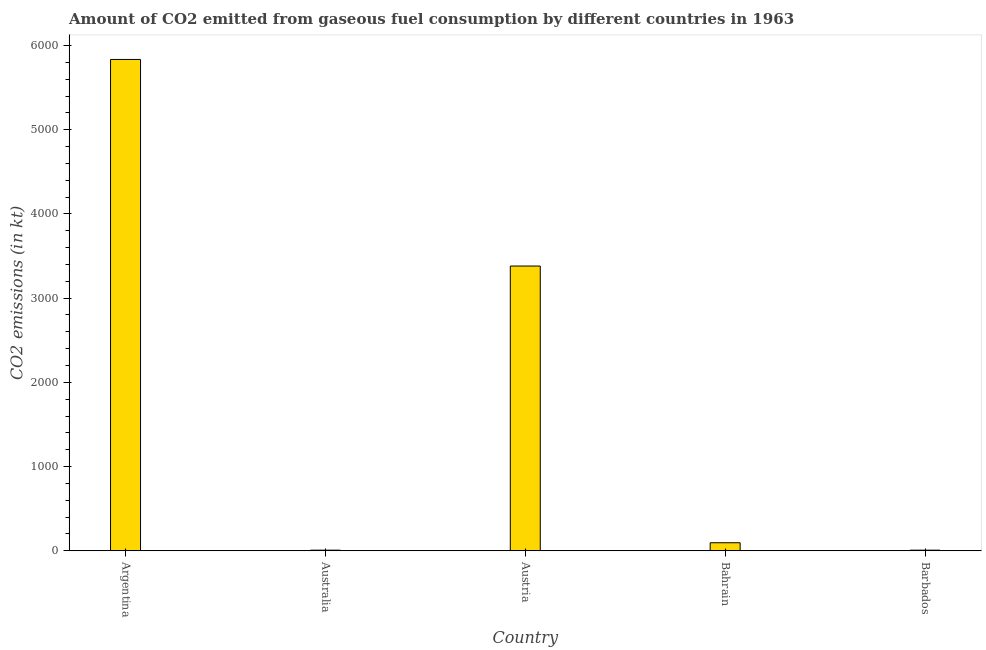Does the graph contain any zero values?
Provide a short and direct response. No. What is the title of the graph?
Ensure brevity in your answer.  Amount of CO2 emitted from gaseous fuel consumption by different countries in 1963. What is the label or title of the X-axis?
Ensure brevity in your answer.  Country. What is the label or title of the Y-axis?
Offer a very short reply. CO2 emissions (in kt). What is the co2 emissions from gaseous fuel consumption in Austria?
Offer a very short reply. 3380.97. Across all countries, what is the maximum co2 emissions from gaseous fuel consumption?
Your answer should be very brief. 5834.2. Across all countries, what is the minimum co2 emissions from gaseous fuel consumption?
Ensure brevity in your answer.  7.33. In which country was the co2 emissions from gaseous fuel consumption maximum?
Your answer should be very brief. Argentina. What is the sum of the co2 emissions from gaseous fuel consumption?
Your answer should be very brief. 9325.18. What is the difference between the co2 emissions from gaseous fuel consumption in Bahrain and Barbados?
Your response must be concise. 88.01. What is the average co2 emissions from gaseous fuel consumption per country?
Your answer should be very brief. 1865.04. What is the median co2 emissions from gaseous fuel consumption?
Provide a succinct answer. 95.34. What is the ratio of the co2 emissions from gaseous fuel consumption in Argentina to that in Bahrain?
Make the answer very short. 61.19. Is the difference between the co2 emissions from gaseous fuel consumption in Australia and Barbados greater than the difference between any two countries?
Provide a short and direct response. No. What is the difference between the highest and the second highest co2 emissions from gaseous fuel consumption?
Your response must be concise. 2453.22. What is the difference between the highest and the lowest co2 emissions from gaseous fuel consumption?
Offer a very short reply. 5826.86. In how many countries, is the co2 emissions from gaseous fuel consumption greater than the average co2 emissions from gaseous fuel consumption taken over all countries?
Your response must be concise. 2. How many bars are there?
Your response must be concise. 5. How many countries are there in the graph?
Offer a terse response. 5. Are the values on the major ticks of Y-axis written in scientific E-notation?
Your answer should be very brief. No. What is the CO2 emissions (in kt) of Argentina?
Your response must be concise. 5834.2. What is the CO2 emissions (in kt) in Australia?
Your answer should be very brief. 7.33. What is the CO2 emissions (in kt) of Austria?
Your answer should be compact. 3380.97. What is the CO2 emissions (in kt) in Bahrain?
Offer a very short reply. 95.34. What is the CO2 emissions (in kt) in Barbados?
Give a very brief answer. 7.33. What is the difference between the CO2 emissions (in kt) in Argentina and Australia?
Make the answer very short. 5826.86. What is the difference between the CO2 emissions (in kt) in Argentina and Austria?
Provide a short and direct response. 2453.22. What is the difference between the CO2 emissions (in kt) in Argentina and Bahrain?
Your response must be concise. 5738.85. What is the difference between the CO2 emissions (in kt) in Argentina and Barbados?
Your answer should be compact. 5826.86. What is the difference between the CO2 emissions (in kt) in Australia and Austria?
Offer a terse response. -3373.64. What is the difference between the CO2 emissions (in kt) in Australia and Bahrain?
Your answer should be compact. -88.01. What is the difference between the CO2 emissions (in kt) in Australia and Barbados?
Provide a succinct answer. 0. What is the difference between the CO2 emissions (in kt) in Austria and Bahrain?
Your response must be concise. 3285.63. What is the difference between the CO2 emissions (in kt) in Austria and Barbados?
Your answer should be compact. 3373.64. What is the difference between the CO2 emissions (in kt) in Bahrain and Barbados?
Give a very brief answer. 88.01. What is the ratio of the CO2 emissions (in kt) in Argentina to that in Australia?
Your answer should be very brief. 795.5. What is the ratio of the CO2 emissions (in kt) in Argentina to that in Austria?
Your answer should be very brief. 1.73. What is the ratio of the CO2 emissions (in kt) in Argentina to that in Bahrain?
Provide a succinct answer. 61.19. What is the ratio of the CO2 emissions (in kt) in Argentina to that in Barbados?
Give a very brief answer. 795.5. What is the ratio of the CO2 emissions (in kt) in Australia to that in Austria?
Your response must be concise. 0. What is the ratio of the CO2 emissions (in kt) in Australia to that in Bahrain?
Keep it short and to the point. 0.08. What is the ratio of the CO2 emissions (in kt) in Australia to that in Barbados?
Make the answer very short. 1. What is the ratio of the CO2 emissions (in kt) in Austria to that in Bahrain?
Provide a succinct answer. 35.46. What is the ratio of the CO2 emissions (in kt) in Austria to that in Barbados?
Provide a succinct answer. 461. 